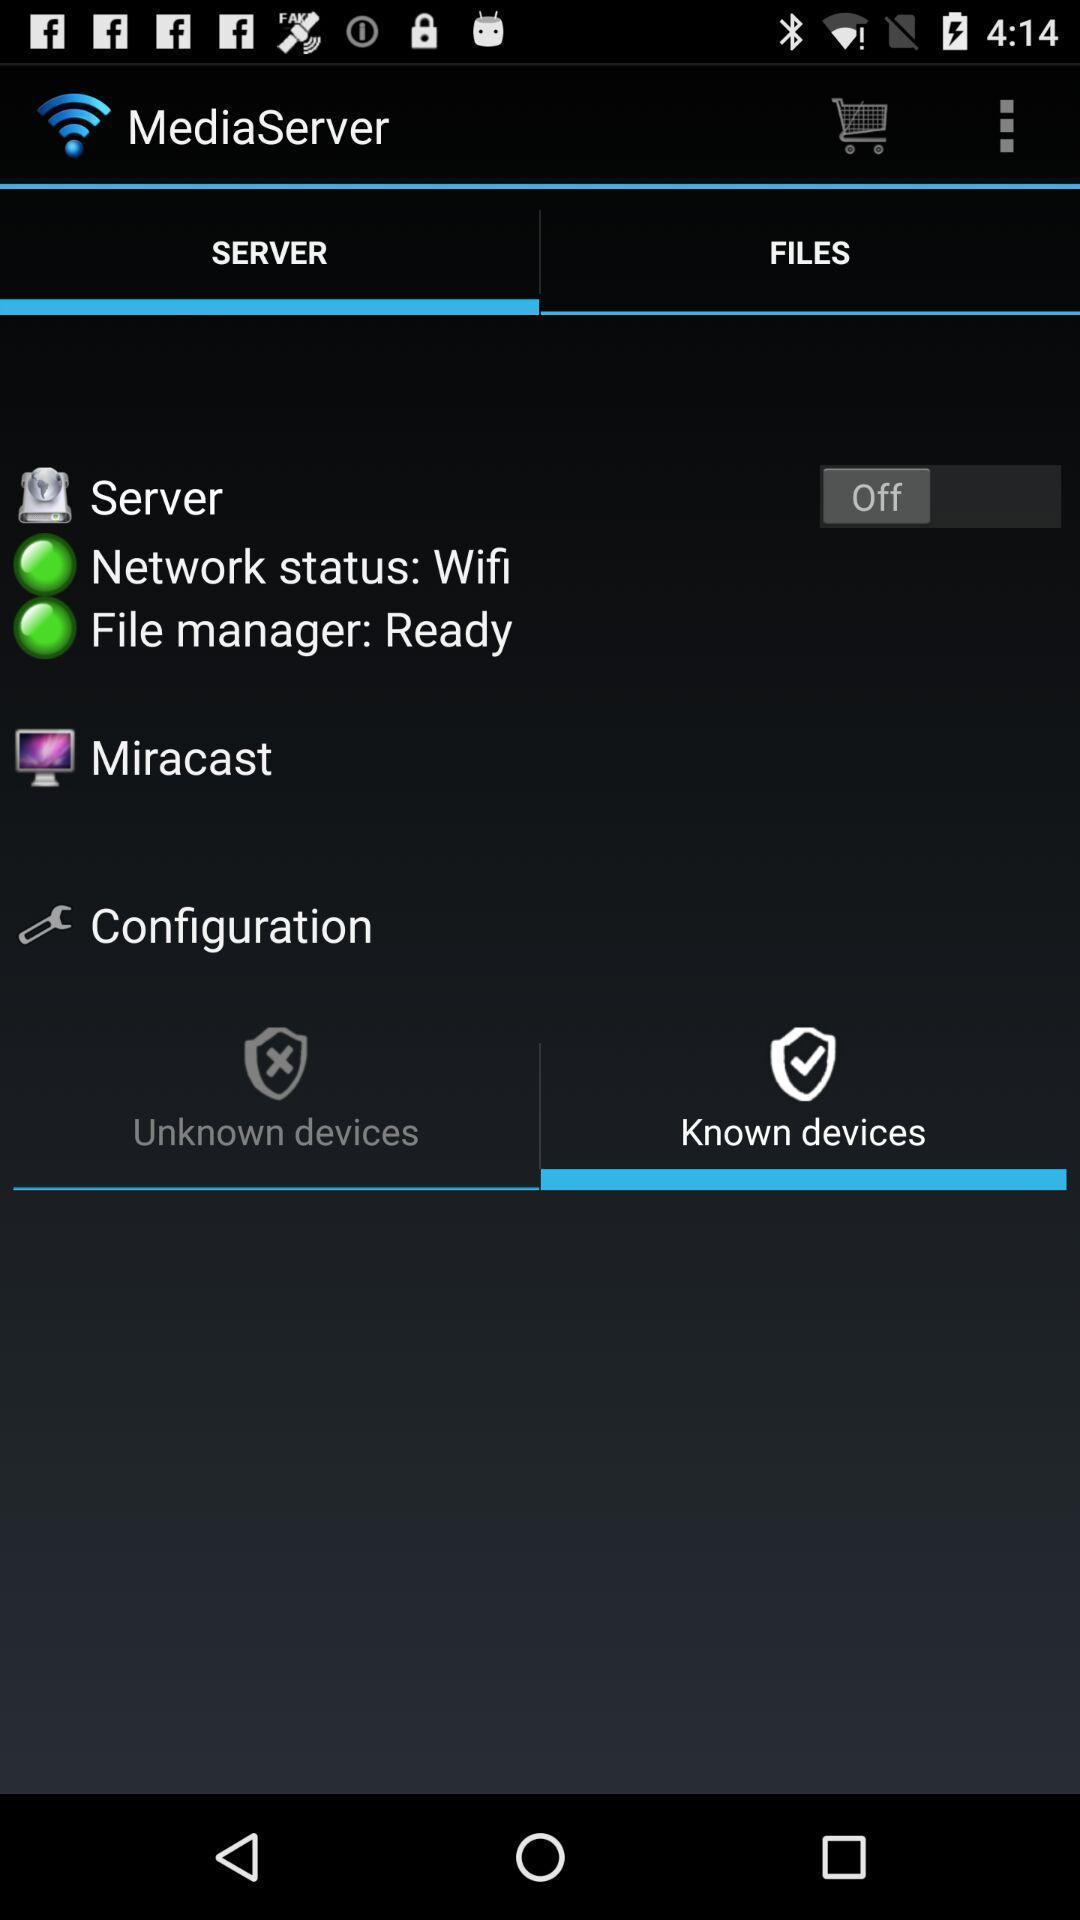Give me a summary of this screen capture. Server details for connectivity. 